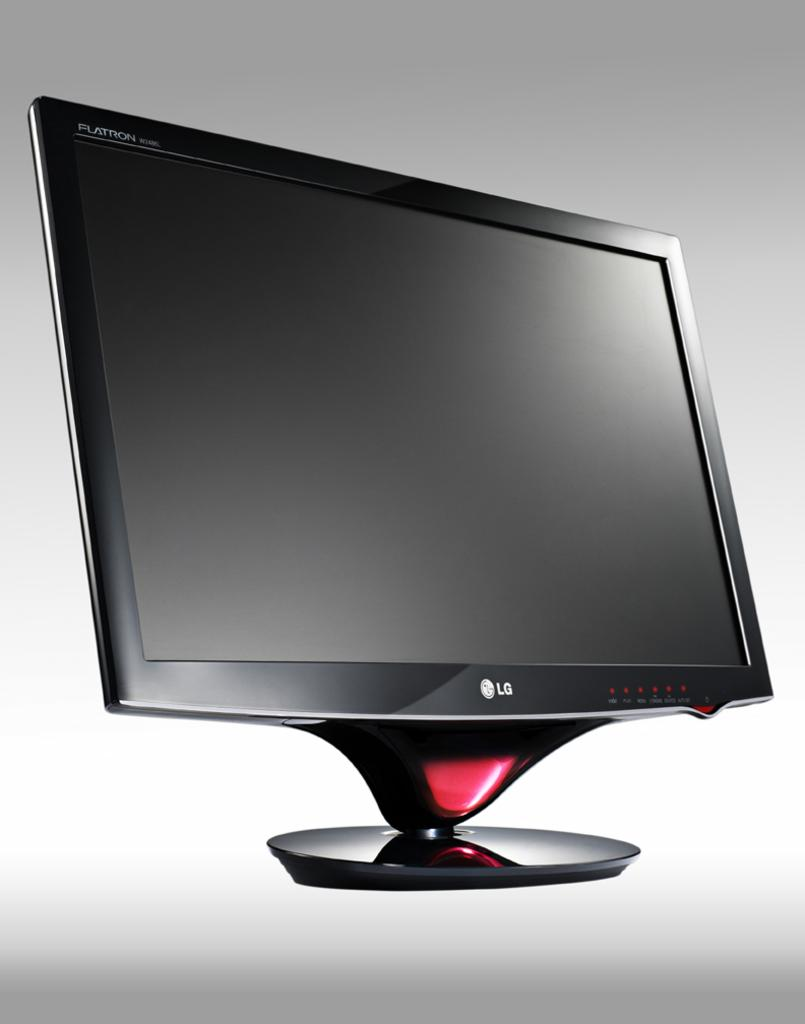<image>
Describe the image concisely. The computer monitor is an LG Flatron with red accents. 